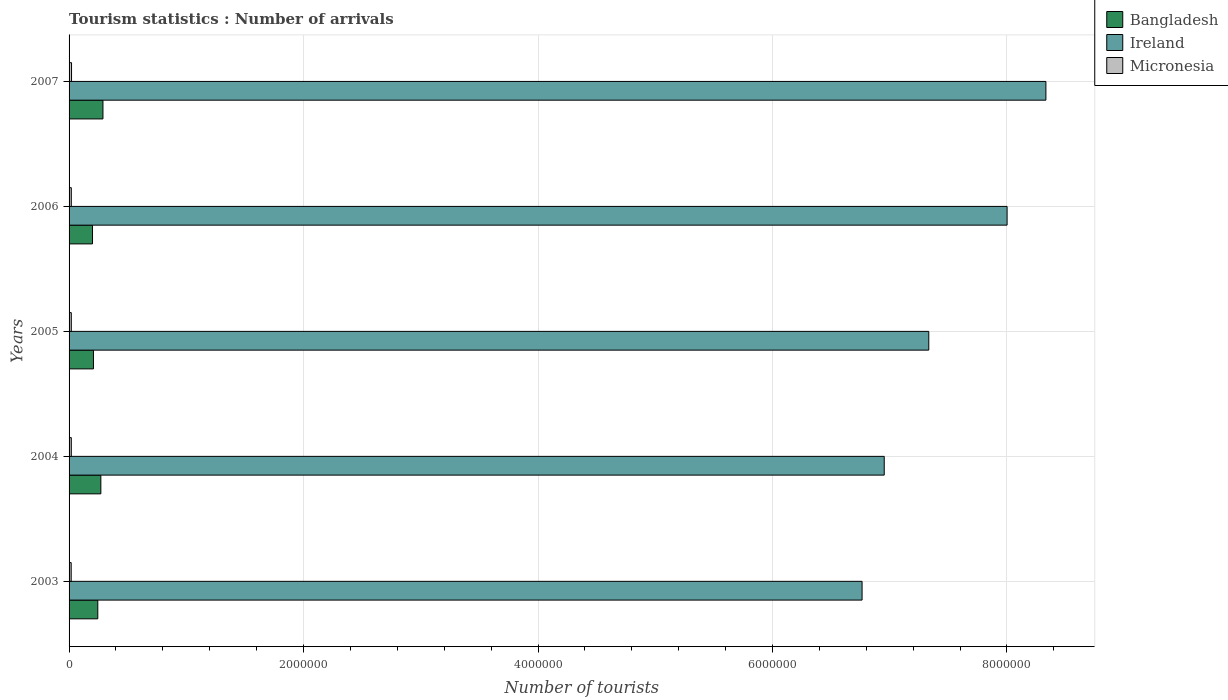Are the number of bars per tick equal to the number of legend labels?
Your answer should be compact. Yes. Are the number of bars on each tick of the Y-axis equal?
Your response must be concise. Yes. How many bars are there on the 2nd tick from the top?
Keep it short and to the point. 3. How many bars are there on the 4th tick from the bottom?
Offer a terse response. 3. In how many cases, is the number of bars for a given year not equal to the number of legend labels?
Your answer should be compact. 0. What is the number of tourist arrivals in Micronesia in 2007?
Keep it short and to the point. 2.10e+04. Across all years, what is the maximum number of tourist arrivals in Bangladesh?
Offer a terse response. 2.89e+05. Across all years, what is the minimum number of tourist arrivals in Bangladesh?
Offer a very short reply. 2.00e+05. In which year was the number of tourist arrivals in Micronesia maximum?
Your answer should be compact. 2007. What is the total number of tourist arrivals in Bangladesh in the graph?
Your response must be concise. 1.21e+06. What is the difference between the number of tourist arrivals in Bangladesh in 2005 and the number of tourist arrivals in Micronesia in 2003?
Give a very brief answer. 1.90e+05. What is the average number of tourist arrivals in Ireland per year?
Your response must be concise. 7.48e+06. In the year 2003, what is the difference between the number of tourist arrivals in Ireland and number of tourist arrivals in Micronesia?
Keep it short and to the point. 6.75e+06. In how many years, is the number of tourist arrivals in Micronesia greater than 4000000 ?
Provide a succinct answer. 0. What is the ratio of the number of tourist arrivals in Bangladesh in 2006 to that in 2007?
Provide a succinct answer. 0.69. Is the number of tourist arrivals in Micronesia in 2004 less than that in 2007?
Keep it short and to the point. Yes. Is the difference between the number of tourist arrivals in Ireland in 2003 and 2006 greater than the difference between the number of tourist arrivals in Micronesia in 2003 and 2006?
Your answer should be very brief. No. What is the difference between the highest and the second highest number of tourist arrivals in Ireland?
Offer a terse response. 3.31e+05. What is the difference between the highest and the lowest number of tourist arrivals in Bangladesh?
Provide a succinct answer. 8.90e+04. In how many years, is the number of tourist arrivals in Bangladesh greater than the average number of tourist arrivals in Bangladesh taken over all years?
Provide a succinct answer. 3. Is the sum of the number of tourist arrivals in Ireland in 2003 and 2006 greater than the maximum number of tourist arrivals in Bangladesh across all years?
Your response must be concise. Yes. What does the 2nd bar from the top in 2005 represents?
Make the answer very short. Ireland. What does the 3rd bar from the bottom in 2006 represents?
Provide a short and direct response. Micronesia. How many bars are there?
Ensure brevity in your answer.  15. What is the difference between two consecutive major ticks on the X-axis?
Provide a succinct answer. 2.00e+06. Are the values on the major ticks of X-axis written in scientific E-notation?
Offer a very short reply. No. Does the graph contain grids?
Provide a succinct answer. Yes. How many legend labels are there?
Your answer should be compact. 3. What is the title of the graph?
Ensure brevity in your answer.  Tourism statistics : Number of arrivals. What is the label or title of the X-axis?
Your answer should be compact. Number of tourists. What is the Number of tourists in Bangladesh in 2003?
Your answer should be compact. 2.45e+05. What is the Number of tourists in Ireland in 2003?
Give a very brief answer. 6.76e+06. What is the Number of tourists of Micronesia in 2003?
Make the answer very short. 1.80e+04. What is the Number of tourists of Bangladesh in 2004?
Make the answer very short. 2.71e+05. What is the Number of tourists of Ireland in 2004?
Offer a very short reply. 6.95e+06. What is the Number of tourists of Micronesia in 2004?
Provide a short and direct response. 1.90e+04. What is the Number of tourists in Bangladesh in 2005?
Provide a short and direct response. 2.08e+05. What is the Number of tourists of Ireland in 2005?
Offer a terse response. 7.33e+06. What is the Number of tourists of Micronesia in 2005?
Give a very brief answer. 1.90e+04. What is the Number of tourists of Bangladesh in 2006?
Provide a succinct answer. 2.00e+05. What is the Number of tourists in Ireland in 2006?
Provide a short and direct response. 8.00e+06. What is the Number of tourists of Micronesia in 2006?
Offer a very short reply. 1.90e+04. What is the Number of tourists of Bangladesh in 2007?
Ensure brevity in your answer.  2.89e+05. What is the Number of tourists of Ireland in 2007?
Give a very brief answer. 8.33e+06. What is the Number of tourists in Micronesia in 2007?
Provide a short and direct response. 2.10e+04. Across all years, what is the maximum Number of tourists of Bangladesh?
Offer a very short reply. 2.89e+05. Across all years, what is the maximum Number of tourists of Ireland?
Your answer should be compact. 8.33e+06. Across all years, what is the maximum Number of tourists of Micronesia?
Provide a short and direct response. 2.10e+04. Across all years, what is the minimum Number of tourists of Bangladesh?
Provide a short and direct response. 2.00e+05. Across all years, what is the minimum Number of tourists of Ireland?
Your answer should be compact. 6.76e+06. Across all years, what is the minimum Number of tourists in Micronesia?
Offer a terse response. 1.80e+04. What is the total Number of tourists in Bangladesh in the graph?
Your response must be concise. 1.21e+06. What is the total Number of tourists in Ireland in the graph?
Your answer should be compact. 3.74e+07. What is the total Number of tourists of Micronesia in the graph?
Your answer should be compact. 9.60e+04. What is the difference between the Number of tourists of Bangladesh in 2003 and that in 2004?
Offer a very short reply. -2.60e+04. What is the difference between the Number of tourists of Ireland in 2003 and that in 2004?
Ensure brevity in your answer.  -1.89e+05. What is the difference between the Number of tourists of Micronesia in 2003 and that in 2004?
Make the answer very short. -1000. What is the difference between the Number of tourists in Bangladesh in 2003 and that in 2005?
Make the answer very short. 3.70e+04. What is the difference between the Number of tourists in Ireland in 2003 and that in 2005?
Your answer should be compact. -5.69e+05. What is the difference between the Number of tourists in Micronesia in 2003 and that in 2005?
Your response must be concise. -1000. What is the difference between the Number of tourists in Bangladesh in 2003 and that in 2006?
Offer a terse response. 4.50e+04. What is the difference between the Number of tourists in Ireland in 2003 and that in 2006?
Your answer should be very brief. -1.24e+06. What is the difference between the Number of tourists of Micronesia in 2003 and that in 2006?
Make the answer very short. -1000. What is the difference between the Number of tourists in Bangladesh in 2003 and that in 2007?
Give a very brief answer. -4.40e+04. What is the difference between the Number of tourists of Ireland in 2003 and that in 2007?
Give a very brief answer. -1.57e+06. What is the difference between the Number of tourists in Micronesia in 2003 and that in 2007?
Keep it short and to the point. -3000. What is the difference between the Number of tourists in Bangladesh in 2004 and that in 2005?
Provide a short and direct response. 6.30e+04. What is the difference between the Number of tourists in Ireland in 2004 and that in 2005?
Offer a very short reply. -3.80e+05. What is the difference between the Number of tourists of Micronesia in 2004 and that in 2005?
Give a very brief answer. 0. What is the difference between the Number of tourists in Bangladesh in 2004 and that in 2006?
Your answer should be very brief. 7.10e+04. What is the difference between the Number of tourists in Ireland in 2004 and that in 2006?
Offer a terse response. -1.05e+06. What is the difference between the Number of tourists in Bangladesh in 2004 and that in 2007?
Your answer should be compact. -1.80e+04. What is the difference between the Number of tourists of Ireland in 2004 and that in 2007?
Your answer should be very brief. -1.38e+06. What is the difference between the Number of tourists of Micronesia in 2004 and that in 2007?
Offer a terse response. -2000. What is the difference between the Number of tourists in Bangladesh in 2005 and that in 2006?
Your response must be concise. 8000. What is the difference between the Number of tourists of Ireland in 2005 and that in 2006?
Ensure brevity in your answer.  -6.68e+05. What is the difference between the Number of tourists of Micronesia in 2005 and that in 2006?
Offer a very short reply. 0. What is the difference between the Number of tourists of Bangladesh in 2005 and that in 2007?
Make the answer very short. -8.10e+04. What is the difference between the Number of tourists in Ireland in 2005 and that in 2007?
Make the answer very short. -9.99e+05. What is the difference between the Number of tourists of Micronesia in 2005 and that in 2007?
Ensure brevity in your answer.  -2000. What is the difference between the Number of tourists of Bangladesh in 2006 and that in 2007?
Your answer should be very brief. -8.90e+04. What is the difference between the Number of tourists in Ireland in 2006 and that in 2007?
Your answer should be very brief. -3.31e+05. What is the difference between the Number of tourists of Micronesia in 2006 and that in 2007?
Your answer should be very brief. -2000. What is the difference between the Number of tourists of Bangladesh in 2003 and the Number of tourists of Ireland in 2004?
Your response must be concise. -6.71e+06. What is the difference between the Number of tourists of Bangladesh in 2003 and the Number of tourists of Micronesia in 2004?
Make the answer very short. 2.26e+05. What is the difference between the Number of tourists of Ireland in 2003 and the Number of tourists of Micronesia in 2004?
Provide a short and direct response. 6.74e+06. What is the difference between the Number of tourists of Bangladesh in 2003 and the Number of tourists of Ireland in 2005?
Offer a terse response. -7.09e+06. What is the difference between the Number of tourists of Bangladesh in 2003 and the Number of tourists of Micronesia in 2005?
Provide a succinct answer. 2.26e+05. What is the difference between the Number of tourists of Ireland in 2003 and the Number of tourists of Micronesia in 2005?
Keep it short and to the point. 6.74e+06. What is the difference between the Number of tourists in Bangladesh in 2003 and the Number of tourists in Ireland in 2006?
Offer a terse response. -7.76e+06. What is the difference between the Number of tourists in Bangladesh in 2003 and the Number of tourists in Micronesia in 2006?
Your response must be concise. 2.26e+05. What is the difference between the Number of tourists of Ireland in 2003 and the Number of tourists of Micronesia in 2006?
Your answer should be compact. 6.74e+06. What is the difference between the Number of tourists in Bangladesh in 2003 and the Number of tourists in Ireland in 2007?
Provide a short and direct response. -8.09e+06. What is the difference between the Number of tourists in Bangladesh in 2003 and the Number of tourists in Micronesia in 2007?
Your response must be concise. 2.24e+05. What is the difference between the Number of tourists in Ireland in 2003 and the Number of tourists in Micronesia in 2007?
Your answer should be compact. 6.74e+06. What is the difference between the Number of tourists in Bangladesh in 2004 and the Number of tourists in Ireland in 2005?
Keep it short and to the point. -7.06e+06. What is the difference between the Number of tourists in Bangladesh in 2004 and the Number of tourists in Micronesia in 2005?
Ensure brevity in your answer.  2.52e+05. What is the difference between the Number of tourists of Ireland in 2004 and the Number of tourists of Micronesia in 2005?
Offer a terse response. 6.93e+06. What is the difference between the Number of tourists of Bangladesh in 2004 and the Number of tourists of Ireland in 2006?
Make the answer very short. -7.73e+06. What is the difference between the Number of tourists in Bangladesh in 2004 and the Number of tourists in Micronesia in 2006?
Make the answer very short. 2.52e+05. What is the difference between the Number of tourists in Ireland in 2004 and the Number of tourists in Micronesia in 2006?
Provide a short and direct response. 6.93e+06. What is the difference between the Number of tourists in Bangladesh in 2004 and the Number of tourists in Ireland in 2007?
Keep it short and to the point. -8.06e+06. What is the difference between the Number of tourists of Ireland in 2004 and the Number of tourists of Micronesia in 2007?
Your answer should be compact. 6.93e+06. What is the difference between the Number of tourists of Bangladesh in 2005 and the Number of tourists of Ireland in 2006?
Ensure brevity in your answer.  -7.79e+06. What is the difference between the Number of tourists of Bangladesh in 2005 and the Number of tourists of Micronesia in 2006?
Make the answer very short. 1.89e+05. What is the difference between the Number of tourists of Ireland in 2005 and the Number of tourists of Micronesia in 2006?
Offer a very short reply. 7.31e+06. What is the difference between the Number of tourists in Bangladesh in 2005 and the Number of tourists in Ireland in 2007?
Provide a succinct answer. -8.12e+06. What is the difference between the Number of tourists in Bangladesh in 2005 and the Number of tourists in Micronesia in 2007?
Your response must be concise. 1.87e+05. What is the difference between the Number of tourists in Ireland in 2005 and the Number of tourists in Micronesia in 2007?
Provide a succinct answer. 7.31e+06. What is the difference between the Number of tourists in Bangladesh in 2006 and the Number of tourists in Ireland in 2007?
Make the answer very short. -8.13e+06. What is the difference between the Number of tourists of Bangladesh in 2006 and the Number of tourists of Micronesia in 2007?
Your response must be concise. 1.79e+05. What is the difference between the Number of tourists in Ireland in 2006 and the Number of tourists in Micronesia in 2007?
Make the answer very short. 7.98e+06. What is the average Number of tourists of Bangladesh per year?
Your response must be concise. 2.43e+05. What is the average Number of tourists of Ireland per year?
Provide a succinct answer. 7.48e+06. What is the average Number of tourists in Micronesia per year?
Make the answer very short. 1.92e+04. In the year 2003, what is the difference between the Number of tourists in Bangladesh and Number of tourists in Ireland?
Your answer should be very brief. -6.52e+06. In the year 2003, what is the difference between the Number of tourists in Bangladesh and Number of tourists in Micronesia?
Offer a very short reply. 2.27e+05. In the year 2003, what is the difference between the Number of tourists of Ireland and Number of tourists of Micronesia?
Offer a terse response. 6.75e+06. In the year 2004, what is the difference between the Number of tourists in Bangladesh and Number of tourists in Ireland?
Provide a succinct answer. -6.68e+06. In the year 2004, what is the difference between the Number of tourists in Bangladesh and Number of tourists in Micronesia?
Offer a terse response. 2.52e+05. In the year 2004, what is the difference between the Number of tourists of Ireland and Number of tourists of Micronesia?
Provide a succinct answer. 6.93e+06. In the year 2005, what is the difference between the Number of tourists of Bangladesh and Number of tourists of Ireland?
Ensure brevity in your answer.  -7.12e+06. In the year 2005, what is the difference between the Number of tourists in Bangladesh and Number of tourists in Micronesia?
Your answer should be very brief. 1.89e+05. In the year 2005, what is the difference between the Number of tourists of Ireland and Number of tourists of Micronesia?
Your answer should be very brief. 7.31e+06. In the year 2006, what is the difference between the Number of tourists of Bangladesh and Number of tourists of Ireland?
Your answer should be very brief. -7.80e+06. In the year 2006, what is the difference between the Number of tourists in Bangladesh and Number of tourists in Micronesia?
Ensure brevity in your answer.  1.81e+05. In the year 2006, what is the difference between the Number of tourists in Ireland and Number of tourists in Micronesia?
Your response must be concise. 7.98e+06. In the year 2007, what is the difference between the Number of tourists of Bangladesh and Number of tourists of Ireland?
Provide a succinct answer. -8.04e+06. In the year 2007, what is the difference between the Number of tourists of Bangladesh and Number of tourists of Micronesia?
Your response must be concise. 2.68e+05. In the year 2007, what is the difference between the Number of tourists of Ireland and Number of tourists of Micronesia?
Your answer should be compact. 8.31e+06. What is the ratio of the Number of tourists in Bangladesh in 2003 to that in 2004?
Your answer should be compact. 0.9. What is the ratio of the Number of tourists of Ireland in 2003 to that in 2004?
Your response must be concise. 0.97. What is the ratio of the Number of tourists in Micronesia in 2003 to that in 2004?
Provide a succinct answer. 0.95. What is the ratio of the Number of tourists in Bangladesh in 2003 to that in 2005?
Make the answer very short. 1.18. What is the ratio of the Number of tourists in Ireland in 2003 to that in 2005?
Keep it short and to the point. 0.92. What is the ratio of the Number of tourists in Bangladesh in 2003 to that in 2006?
Your response must be concise. 1.23. What is the ratio of the Number of tourists in Ireland in 2003 to that in 2006?
Ensure brevity in your answer.  0.85. What is the ratio of the Number of tourists in Bangladesh in 2003 to that in 2007?
Offer a very short reply. 0.85. What is the ratio of the Number of tourists of Ireland in 2003 to that in 2007?
Your answer should be compact. 0.81. What is the ratio of the Number of tourists in Bangladesh in 2004 to that in 2005?
Provide a short and direct response. 1.3. What is the ratio of the Number of tourists of Ireland in 2004 to that in 2005?
Offer a terse response. 0.95. What is the ratio of the Number of tourists of Bangladesh in 2004 to that in 2006?
Offer a very short reply. 1.35. What is the ratio of the Number of tourists of Ireland in 2004 to that in 2006?
Your response must be concise. 0.87. What is the ratio of the Number of tourists of Bangladesh in 2004 to that in 2007?
Your answer should be very brief. 0.94. What is the ratio of the Number of tourists of Ireland in 2004 to that in 2007?
Ensure brevity in your answer.  0.83. What is the ratio of the Number of tourists of Micronesia in 2004 to that in 2007?
Your answer should be very brief. 0.9. What is the ratio of the Number of tourists of Ireland in 2005 to that in 2006?
Offer a terse response. 0.92. What is the ratio of the Number of tourists in Bangladesh in 2005 to that in 2007?
Offer a terse response. 0.72. What is the ratio of the Number of tourists of Ireland in 2005 to that in 2007?
Offer a very short reply. 0.88. What is the ratio of the Number of tourists in Micronesia in 2005 to that in 2007?
Provide a short and direct response. 0.9. What is the ratio of the Number of tourists of Bangladesh in 2006 to that in 2007?
Your response must be concise. 0.69. What is the ratio of the Number of tourists of Ireland in 2006 to that in 2007?
Keep it short and to the point. 0.96. What is the ratio of the Number of tourists in Micronesia in 2006 to that in 2007?
Provide a succinct answer. 0.9. What is the difference between the highest and the second highest Number of tourists in Bangladesh?
Your response must be concise. 1.80e+04. What is the difference between the highest and the second highest Number of tourists in Ireland?
Offer a very short reply. 3.31e+05. What is the difference between the highest and the lowest Number of tourists of Bangladesh?
Offer a very short reply. 8.90e+04. What is the difference between the highest and the lowest Number of tourists of Ireland?
Your answer should be compact. 1.57e+06. What is the difference between the highest and the lowest Number of tourists in Micronesia?
Give a very brief answer. 3000. 